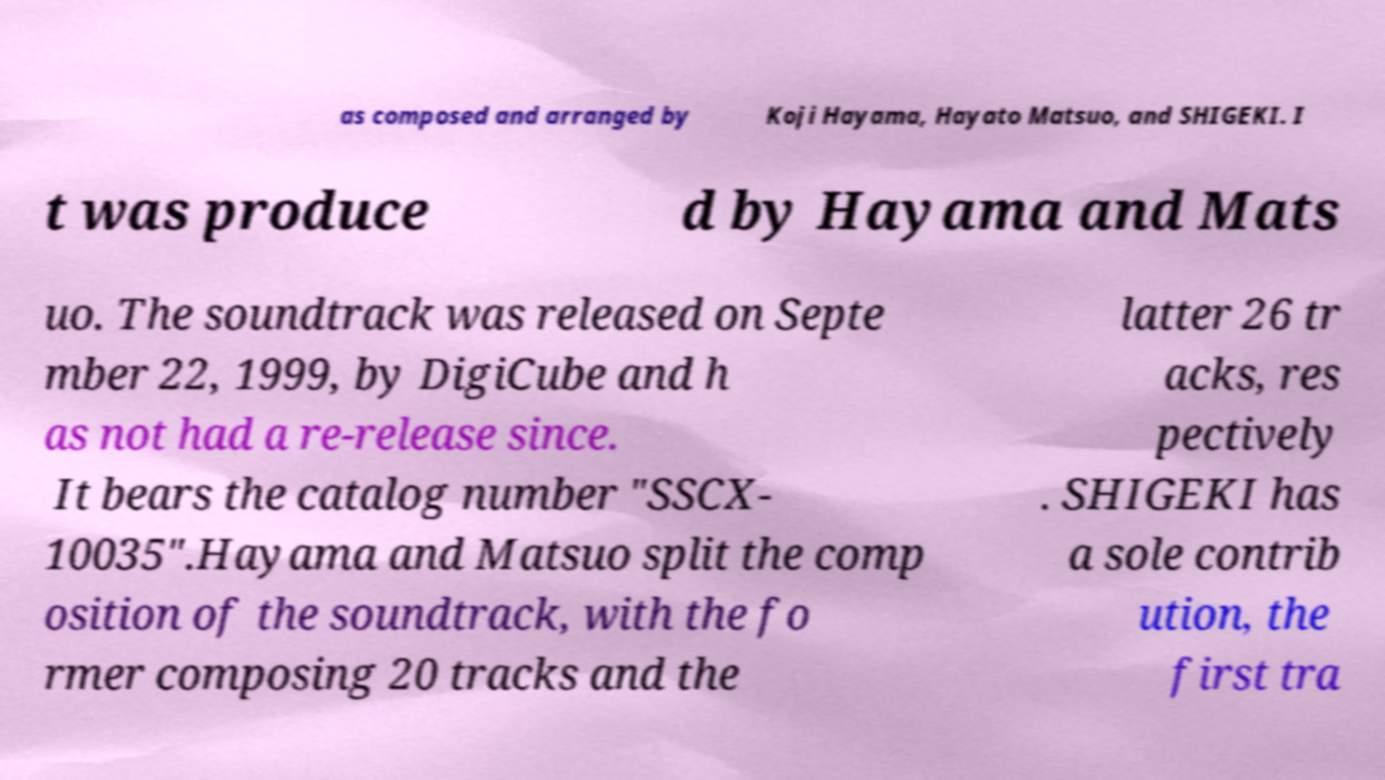For documentation purposes, I need the text within this image transcribed. Could you provide that? as composed and arranged by Koji Hayama, Hayato Matsuo, and SHIGEKI. I t was produce d by Hayama and Mats uo. The soundtrack was released on Septe mber 22, 1999, by DigiCube and h as not had a re-release since. It bears the catalog number "SSCX- 10035".Hayama and Matsuo split the comp osition of the soundtrack, with the fo rmer composing 20 tracks and the latter 26 tr acks, res pectively . SHIGEKI has a sole contrib ution, the first tra 